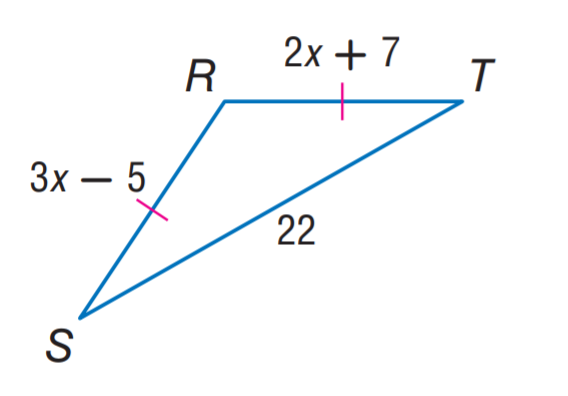Answer the mathemtical geometry problem and directly provide the correct option letter.
Question: Find R T.
Choices: A: 12 B: 22 C: 31 D: 33 C 